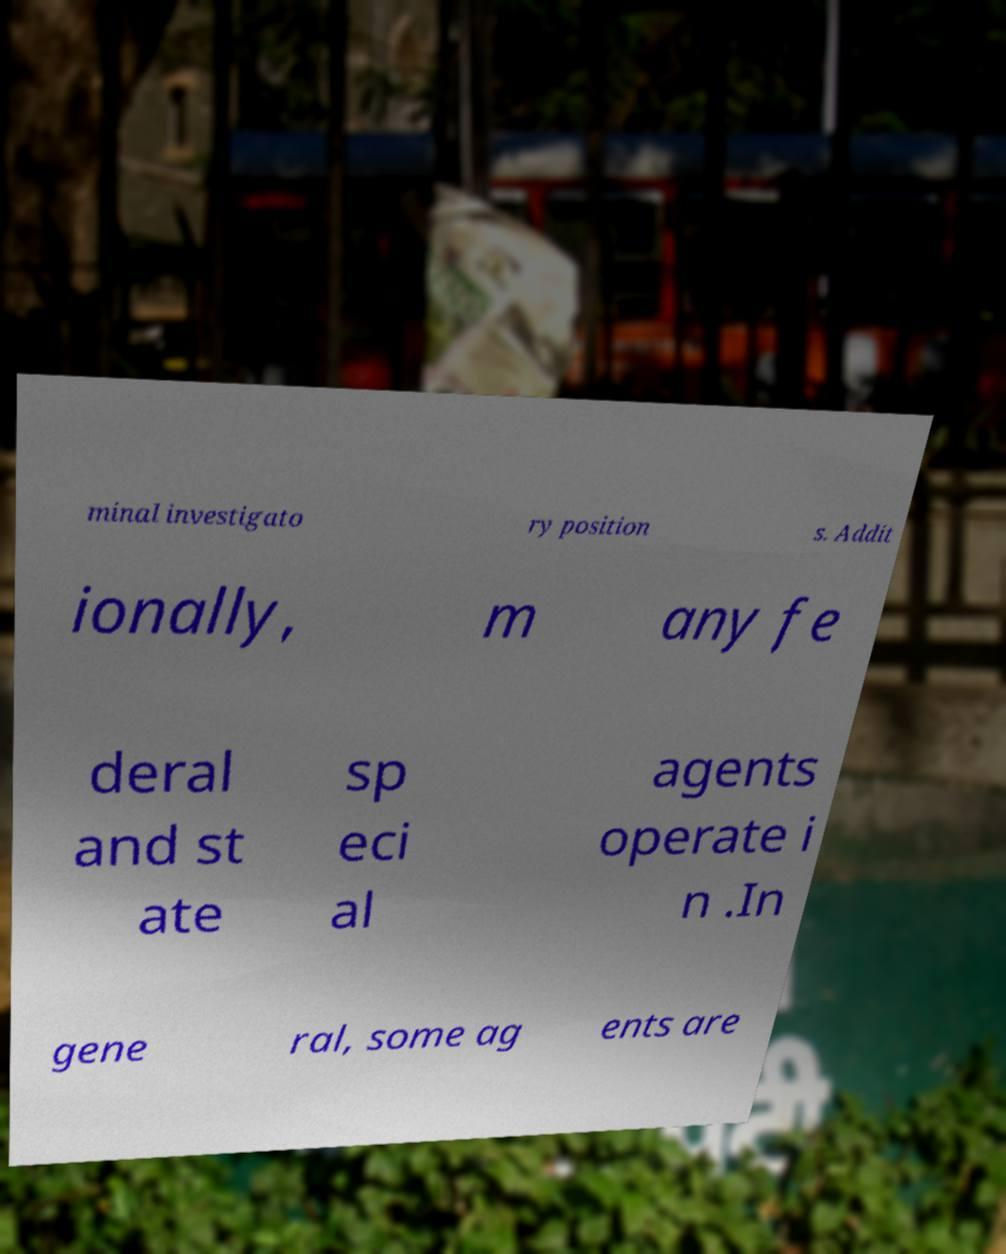Can you accurately transcribe the text from the provided image for me? minal investigato ry position s. Addit ionally, m any fe deral and st ate sp eci al agents operate i n .In gene ral, some ag ents are 